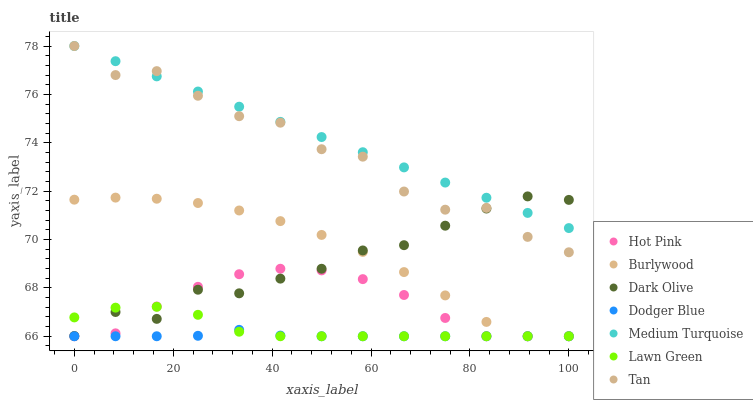Does Dodger Blue have the minimum area under the curve?
Answer yes or no. Yes. Does Medium Turquoise have the maximum area under the curve?
Answer yes or no. Yes. Does Dark Olive have the minimum area under the curve?
Answer yes or no. No. Does Dark Olive have the maximum area under the curve?
Answer yes or no. No. Is Medium Turquoise the smoothest?
Answer yes or no. Yes. Is Tan the roughest?
Answer yes or no. Yes. Is Dark Olive the smoothest?
Answer yes or no. No. Is Dark Olive the roughest?
Answer yes or no. No. Does Lawn Green have the lowest value?
Answer yes or no. Yes. Does Dark Olive have the lowest value?
Answer yes or no. No. Does Tan have the highest value?
Answer yes or no. Yes. Does Dark Olive have the highest value?
Answer yes or no. No. Is Dodger Blue less than Medium Turquoise?
Answer yes or no. Yes. Is Medium Turquoise greater than Burlywood?
Answer yes or no. Yes. Does Medium Turquoise intersect Dark Olive?
Answer yes or no. Yes. Is Medium Turquoise less than Dark Olive?
Answer yes or no. No. Is Medium Turquoise greater than Dark Olive?
Answer yes or no. No. Does Dodger Blue intersect Medium Turquoise?
Answer yes or no. No. 